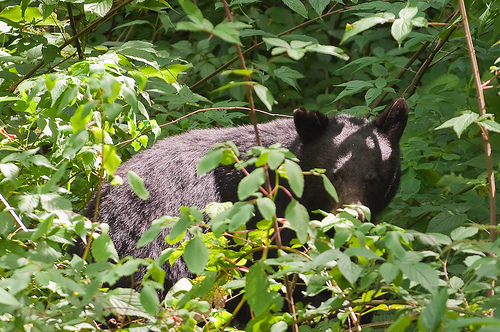<image>
Can you confirm if the bear is under the leaves? Yes. The bear is positioned underneath the leaves, with the leaves above it in the vertical space. 